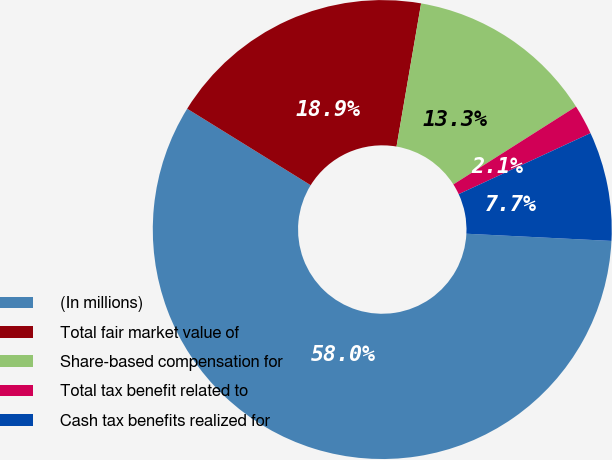Convert chart to OTSL. <chart><loc_0><loc_0><loc_500><loc_500><pie_chart><fcel>(In millions)<fcel>Total fair market value of<fcel>Share-based compensation for<fcel>Total tax benefit related to<fcel>Cash tax benefits realized for<nl><fcel>58.03%<fcel>18.88%<fcel>13.29%<fcel>2.1%<fcel>7.69%<nl></chart> 